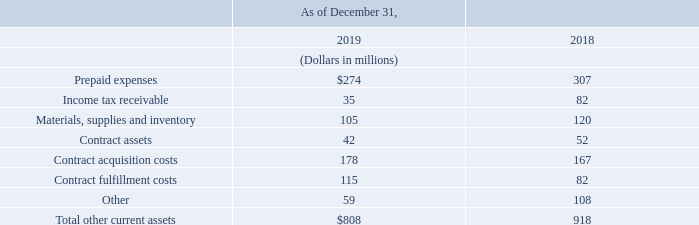Other Current Assets
The following table presents details of other current assets in our consolidated balance sheets:
What is the amount of contract assets in 2019?
Answer scale should be: million. 42. What is the amount of contract acquisition costs in 2019?
Answer scale should be: million. 178. What are the different segments of other current assets highlighted in the table? Prepaid expenses, income tax receivable, materials, supplies and inventory, contract assets, contract acquisition costs, contract fulfillment costs, other. Which year has a larger amount of contract acquisition costs? 178>167
Answer: 2019. What is the change in contract assets in 2019?
Answer scale should be: million. 42-52
Answer: -10. What is the percentage change in total other current assets in 2019?
Answer scale should be: percent. (808-918)/918
Answer: -11.98. 